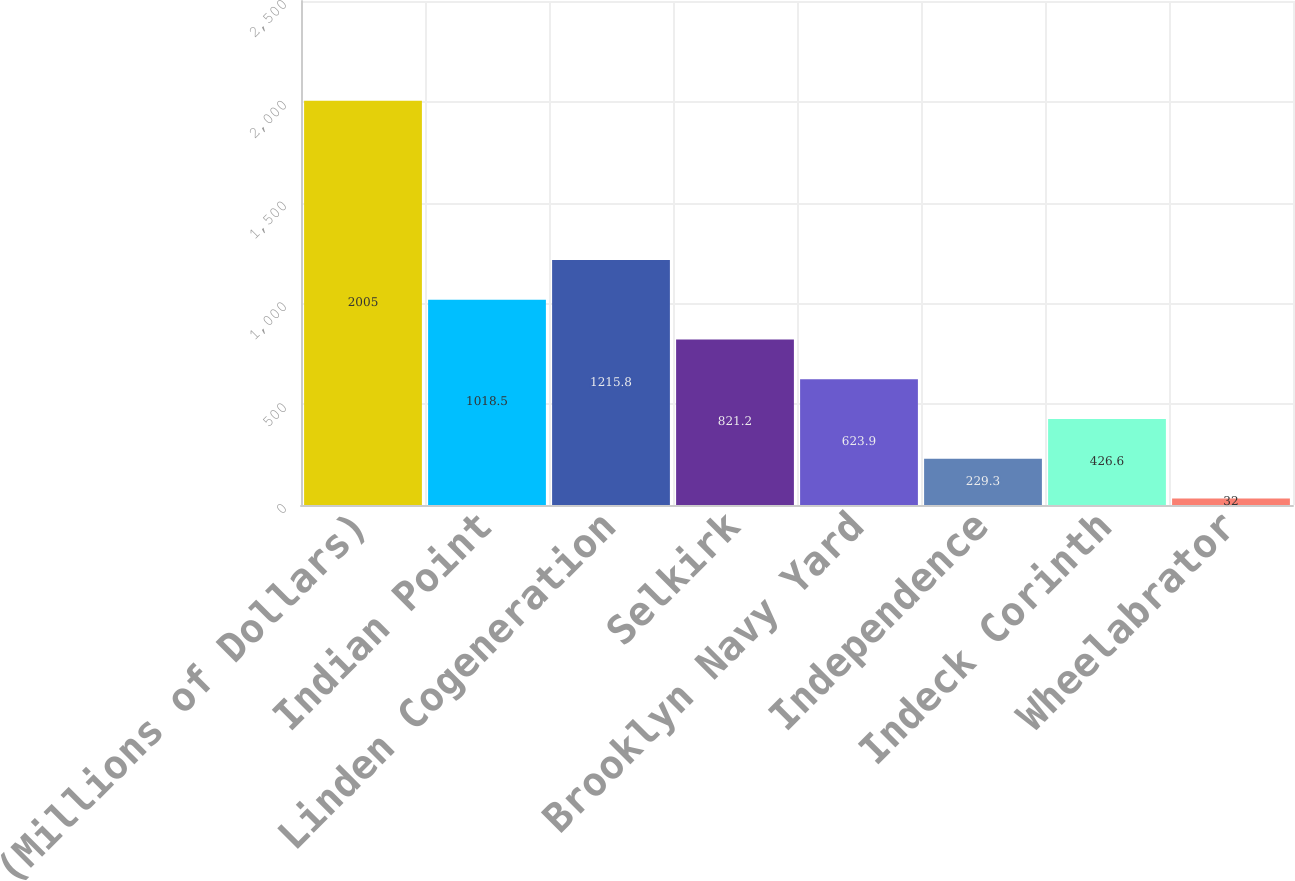Convert chart to OTSL. <chart><loc_0><loc_0><loc_500><loc_500><bar_chart><fcel>(Millions of Dollars)<fcel>Indian Point<fcel>Linden Cogeneration<fcel>Selkirk<fcel>Brooklyn Navy Yard<fcel>Independence<fcel>Indeck Corinth<fcel>Wheelabrator<nl><fcel>2005<fcel>1018.5<fcel>1215.8<fcel>821.2<fcel>623.9<fcel>229.3<fcel>426.6<fcel>32<nl></chart> 